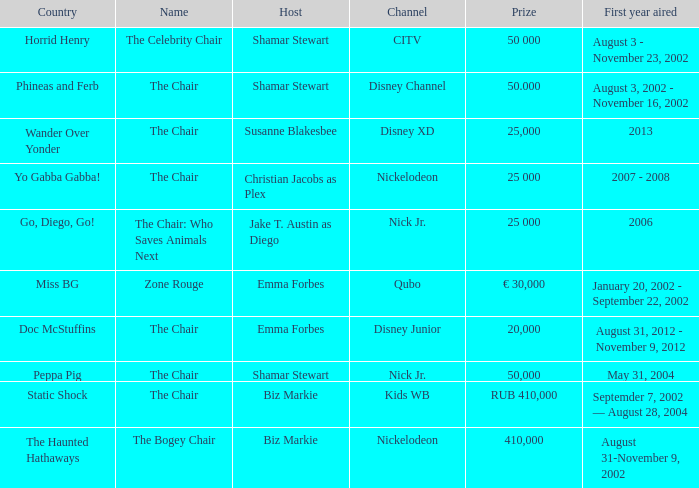What was the host of Horrid Henry? Shamar Stewart. 